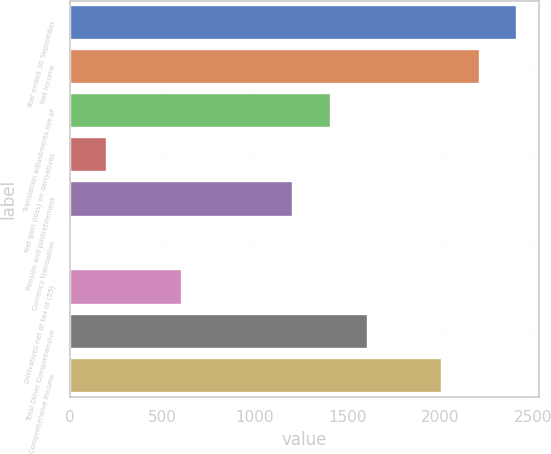Convert chart. <chart><loc_0><loc_0><loc_500><loc_500><bar_chart><fcel>Year ended 30 September<fcel>Net Income<fcel>Translation adjustments net of<fcel>Net gain (loss) on derivatives<fcel>Pension and postretirement<fcel>Currency translation<fcel>Derivatives net of tax of (55)<fcel>Total Other Comprehensive<fcel>Comprehensive Income<nl><fcel>2413.12<fcel>2212.06<fcel>1407.82<fcel>201.46<fcel>1206.76<fcel>0.4<fcel>603.58<fcel>1608.88<fcel>2011<nl></chart> 